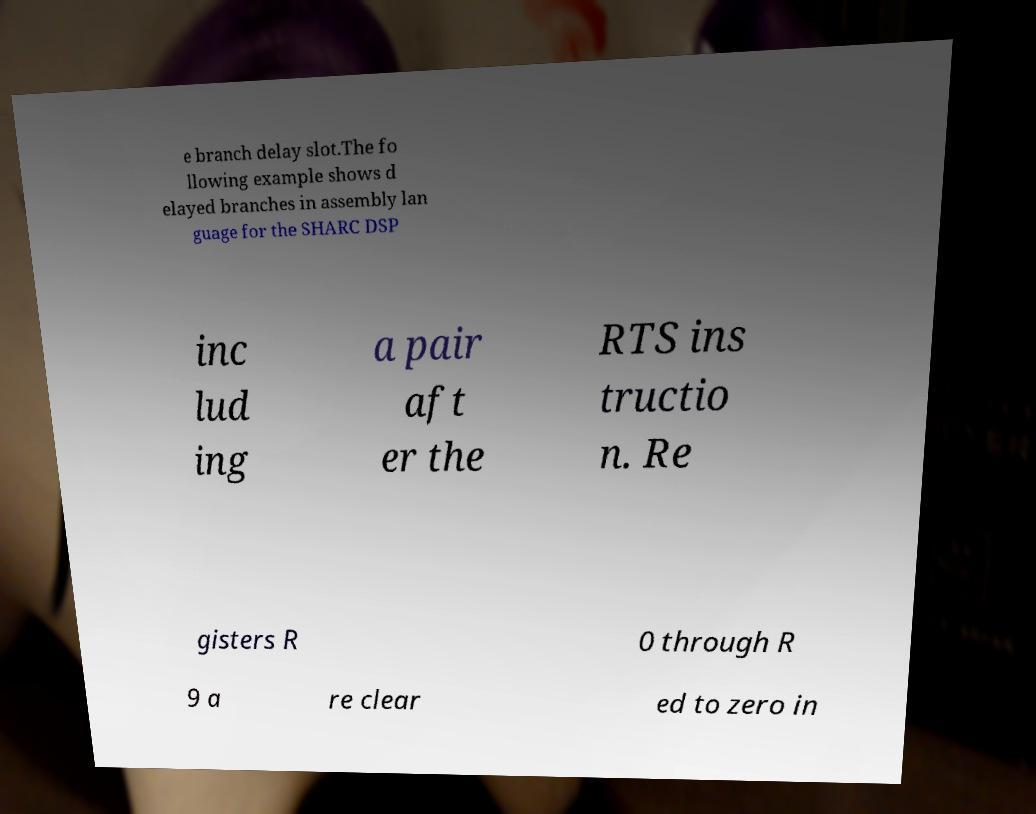Could you extract and type out the text from this image? e branch delay slot.The fo llowing example shows d elayed branches in assembly lan guage for the SHARC DSP inc lud ing a pair aft er the RTS ins tructio n. Re gisters R 0 through R 9 a re clear ed to zero in 